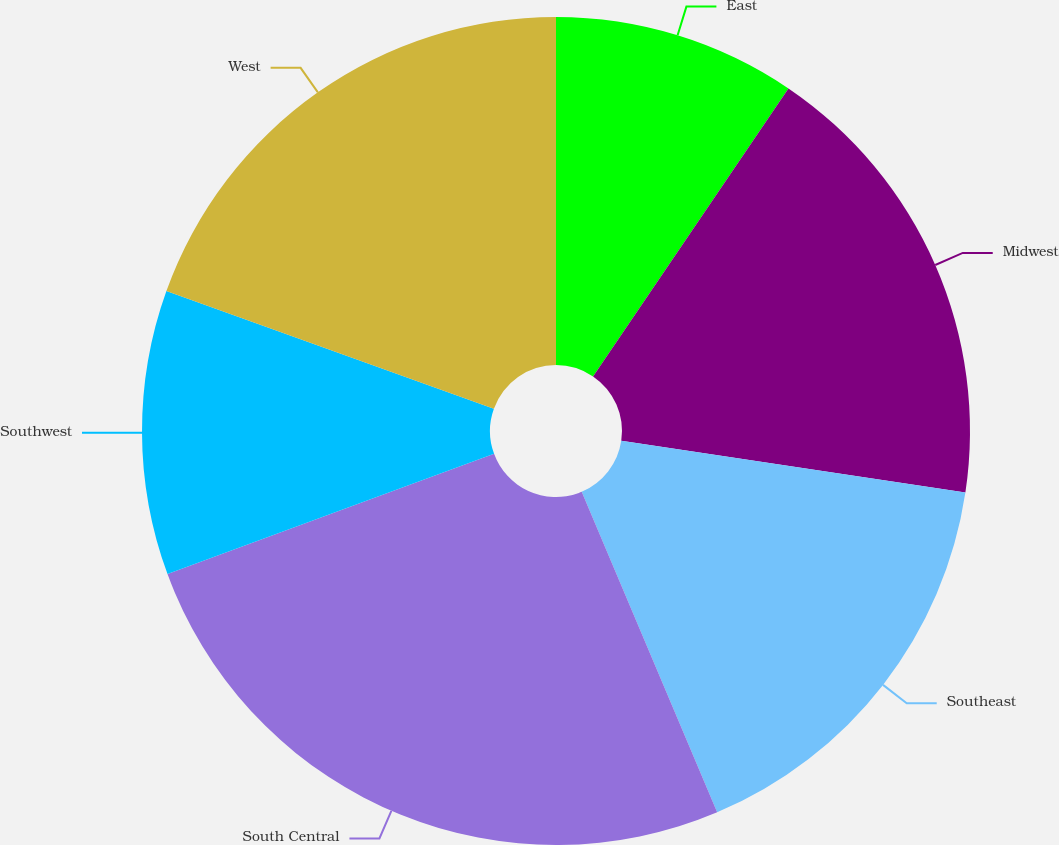Convert chart to OTSL. <chart><loc_0><loc_0><loc_500><loc_500><pie_chart><fcel>East<fcel>Midwest<fcel>Southeast<fcel>South Central<fcel>Southwest<fcel>West<nl><fcel>9.49%<fcel>17.89%<fcel>16.26%<fcel>25.75%<fcel>11.11%<fcel>19.51%<nl></chart> 